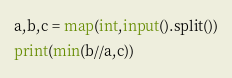Convert code to text. <code><loc_0><loc_0><loc_500><loc_500><_Python_>a,b,c = map(int,input().split())
print(min(b//a,c))</code> 